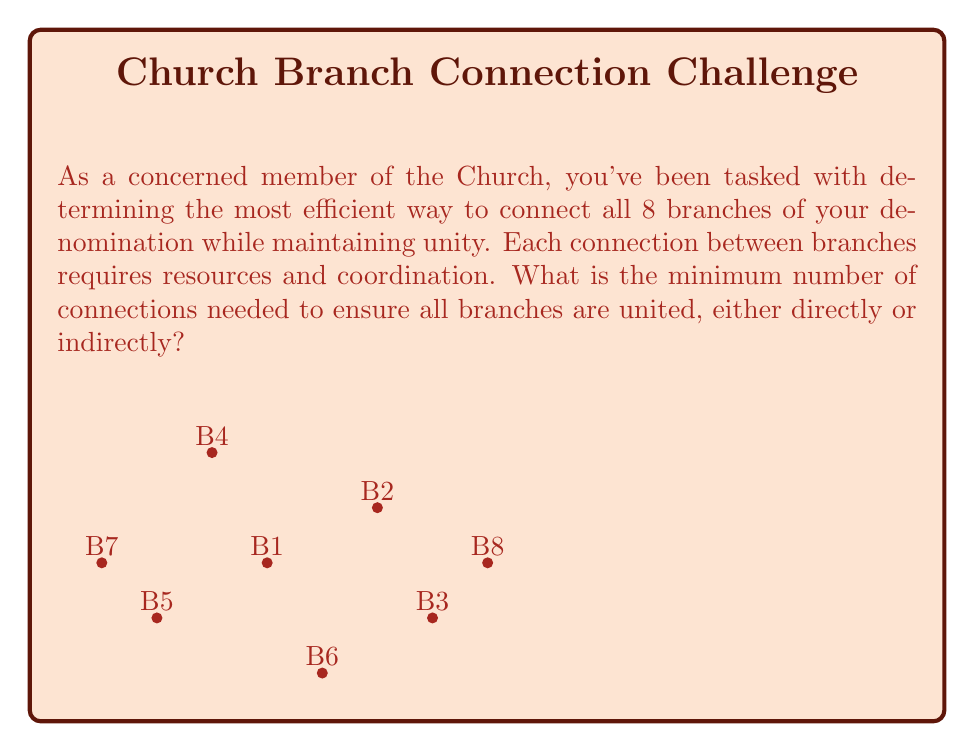Help me with this question. To solve this problem, we can use concepts from graph theory, specifically the idea of a minimum spanning tree.

1) In graph theory, each branch can be considered a vertex, and each connection between branches an edge.

2) The problem of connecting all branches with the minimum number of connections is equivalent to finding a minimum spanning tree in a graph.

3) A key property of trees is that for $n$ vertices, a tree will have exactly $n-1$ edges.

4) This property ensures that all vertices are connected with the minimum number of edges, without forming any cycles (which would be redundant connections).

5) In our case, we have 8 branches (vertices), so the minimum number of connections (edges) needed is:

   $$\text{Number of connections} = n - 1 = 8 - 1 = 7$$

6) This solution ensures that all branches are connected, either directly or indirectly, using the fewest possible connections.

7) The specific configuration of these 7 connections can vary, but the number will always be 7 for 8 branches.

This approach minimizes resource usage and coordination efforts while ensuring all branches remain united within the Church structure.
Answer: 7 connections 